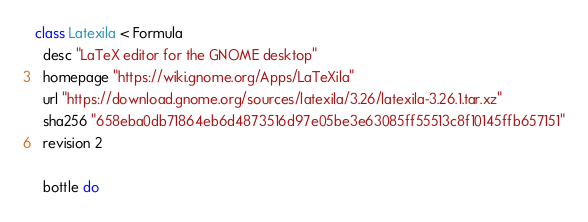Convert code to text. <code><loc_0><loc_0><loc_500><loc_500><_Ruby_>class Latexila < Formula
  desc "LaTeX editor for the GNOME desktop"
  homepage "https://wiki.gnome.org/Apps/LaTeXila"
  url "https://download.gnome.org/sources/latexila/3.26/latexila-3.26.1.tar.xz"
  sha256 "658eba0db71864eb6d4873516d97e05be3e63085ff55513c8f10145ffb657151"
  revision 2

  bottle do</code> 